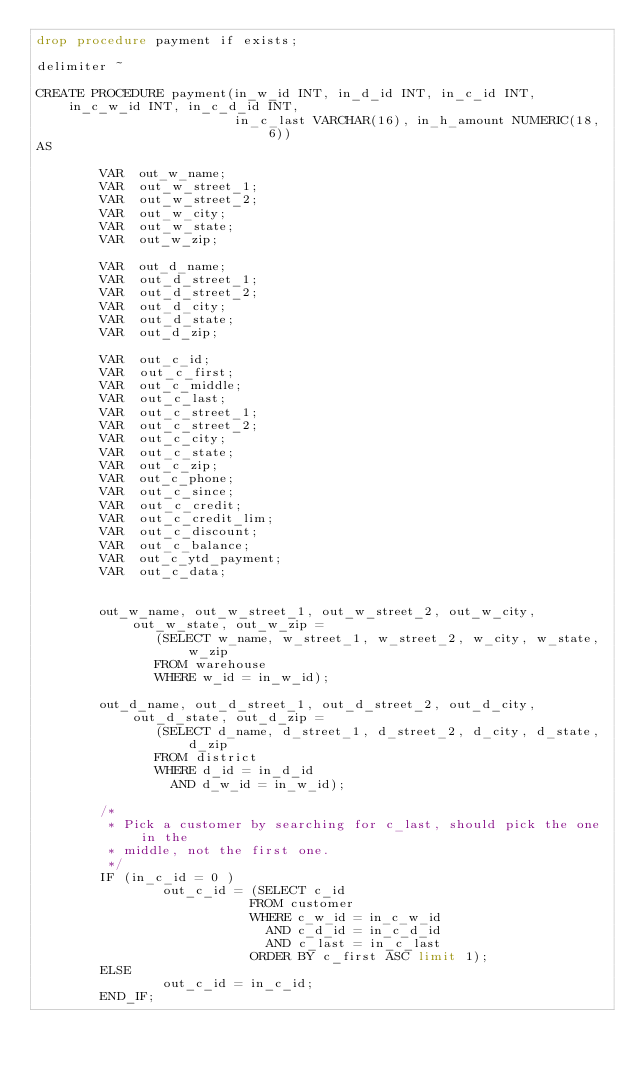Convert code to text. <code><loc_0><loc_0><loc_500><loc_500><_SQL_>drop procedure payment if exists;

delimiter ~

CREATE PROCEDURE payment(in_w_id INT, in_d_id INT, in_c_id INT, in_c_w_id INT, in_c_d_id INT,
                         in_c_last VARCHAR(16), in_h_amount NUMERIC(18, 6))
AS

        VAR  out_w_name;
        VAR  out_w_street_1;
        VAR  out_w_street_2;
        VAR  out_w_city;
        VAR  out_w_state;
        VAR  out_w_zip;

        VAR  out_d_name;
        VAR  out_d_street_1;
        VAR  out_d_street_2;
        VAR  out_d_city;
        VAR  out_d_state;
        VAR  out_d_zip;

        VAR  out_c_id;
        VAR  out_c_first;
        VAR  out_c_middle;
        VAR  out_c_last;
        VAR  out_c_street_1;
        VAR  out_c_street_2;
        VAR  out_c_city;
        VAR  out_c_state;
        VAR  out_c_zip;
        VAR  out_c_phone;
        VAR  out_c_since;
        VAR  out_c_credit;
        VAR  out_c_credit_lim;
        VAR  out_c_discount;
        VAR  out_c_balance;
        VAR  out_c_ytd_payment;
        VAR  out_c_data;


        out_w_name, out_w_street_1, out_w_street_2, out_w_city, out_w_state, out_w_zip =
               (SELECT w_name, w_street_1, w_street_2, w_city, w_state, w_zip
               FROM warehouse
               WHERE w_id = in_w_id);

        out_d_name, out_d_street_1, out_d_street_2, out_d_city, out_d_state, out_d_zip =
               (SELECT d_name, d_street_1, d_street_2, d_city, d_state, d_zip
               FROM district
               WHERE d_id = in_d_id
                 AND d_w_id = in_w_id);

        /*
         * Pick a customer by searching for c_last, should pick the one in the
         * middle, not the first one.
         */
        IF (in_c_id = 0 )
                out_c_id = (SELECT c_id
                           FROM customer
                           WHERE c_w_id = in_c_w_id
                             AND c_d_id = in_c_d_id
                             AND c_last = in_c_last
                           ORDER BY c_first ASC limit 1);
        ELSE
                out_c_id = in_c_id;
        END_IF;
</code> 